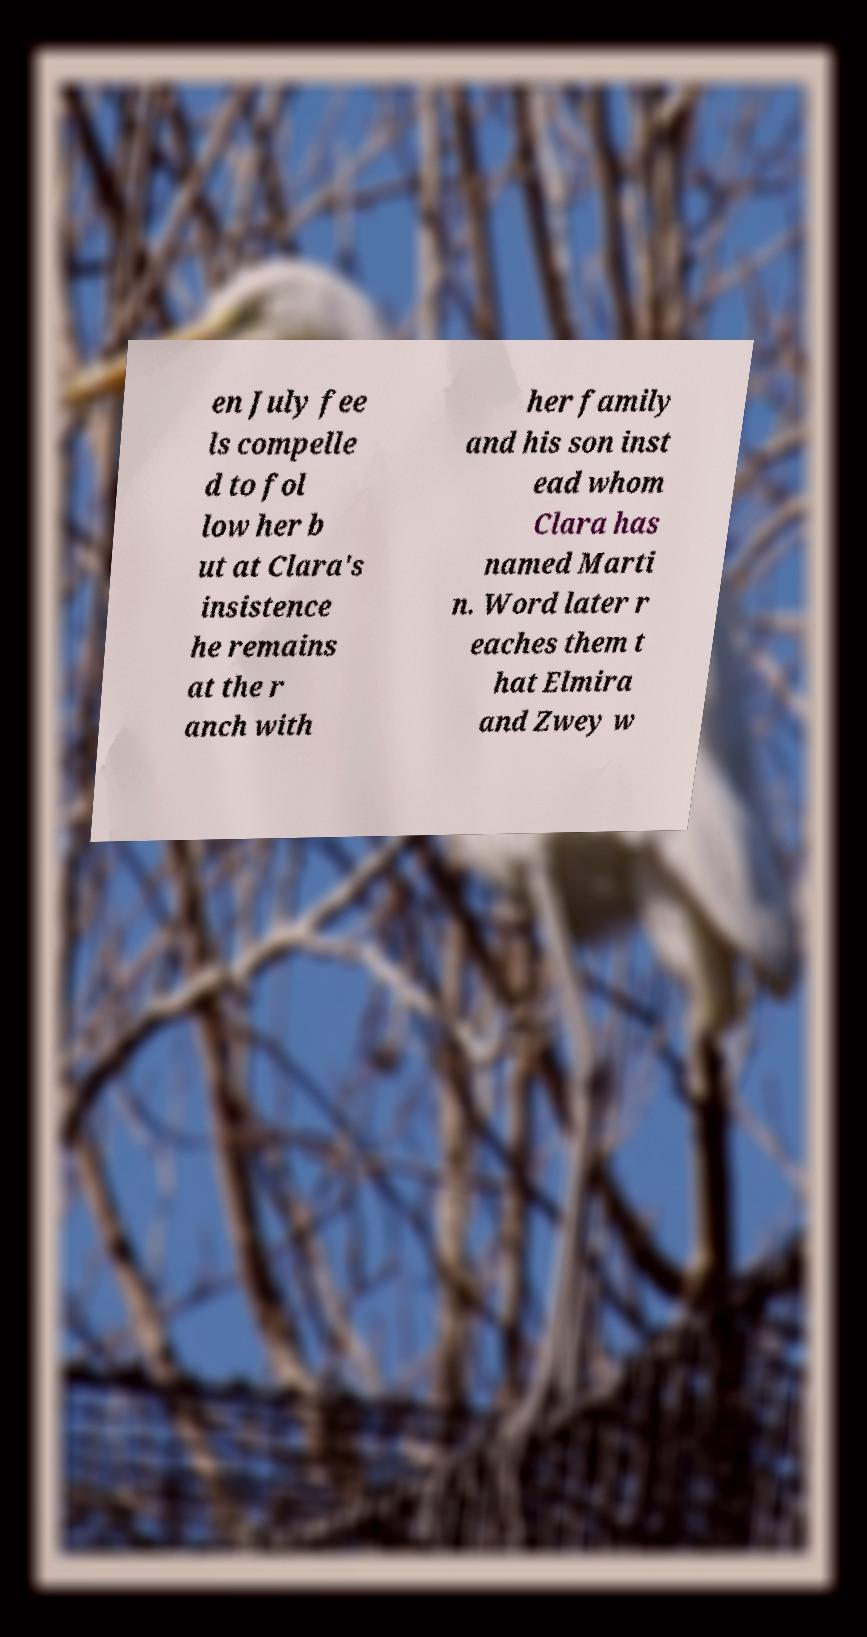Could you extract and type out the text from this image? en July fee ls compelle d to fol low her b ut at Clara's insistence he remains at the r anch with her family and his son inst ead whom Clara has named Marti n. Word later r eaches them t hat Elmira and Zwey w 